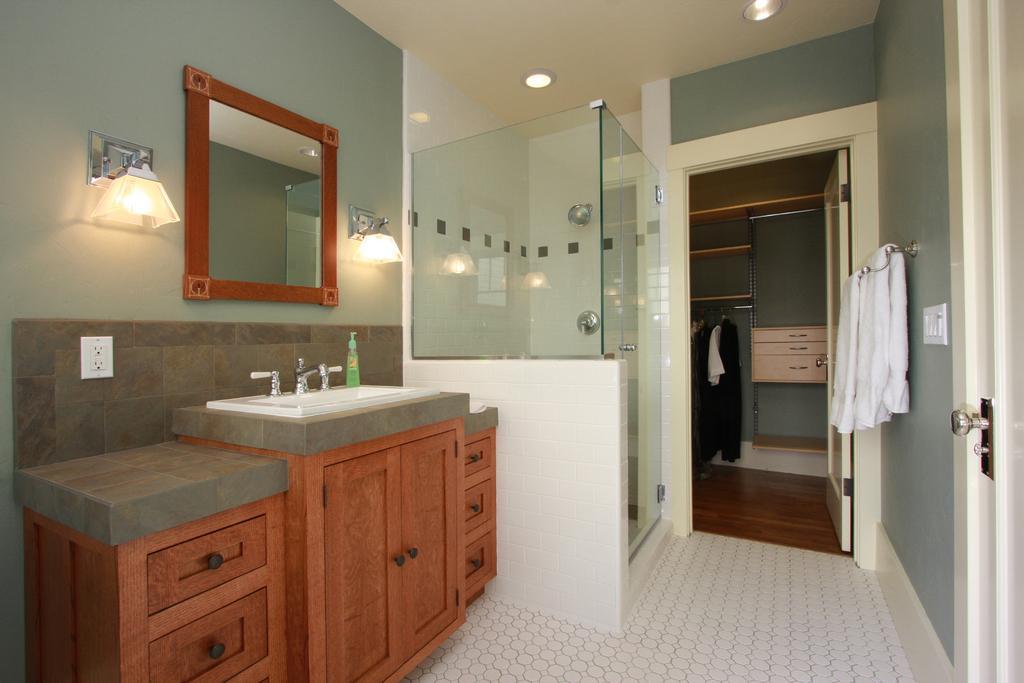Please provide a concise description of this image. In this image we can see the inner view of a room. In the room there are electric lights, clothes hanged to the hangers, cupboards, sink, taps, daily essentials and a mirror. 